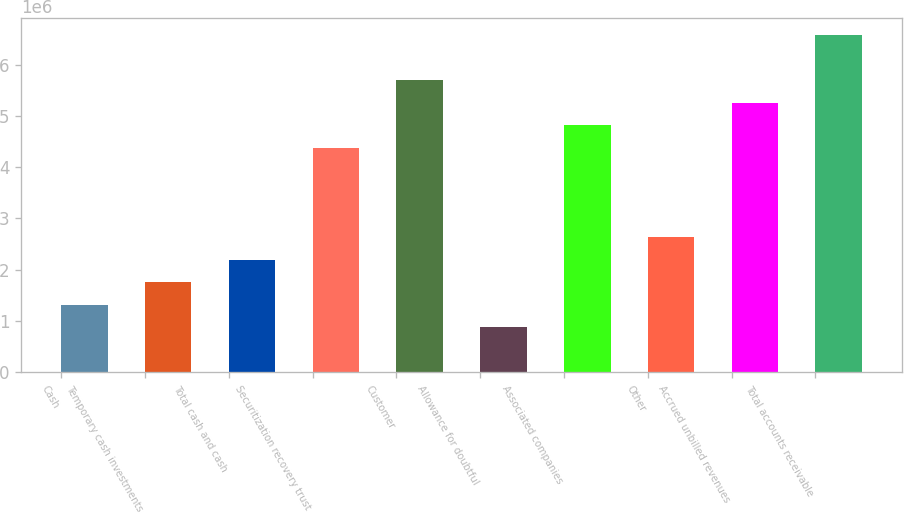Convert chart. <chart><loc_0><loc_0><loc_500><loc_500><bar_chart><fcel>Cash<fcel>Temporary cash investments<fcel>Total cash and cash<fcel>Securitization recovery trust<fcel>Customer<fcel>Allowance for doubtful<fcel>Associated companies<fcel>Other<fcel>Accrued unbilled revenues<fcel>Total accounts receivable<nl><fcel>1.31585e+06<fcel>1.75434e+06<fcel>2.19284e+06<fcel>4.3853e+06<fcel>5.70077e+06<fcel>877360<fcel>4.82379e+06<fcel>2.63133e+06<fcel>5.26228e+06<fcel>6.57776e+06<nl></chart> 